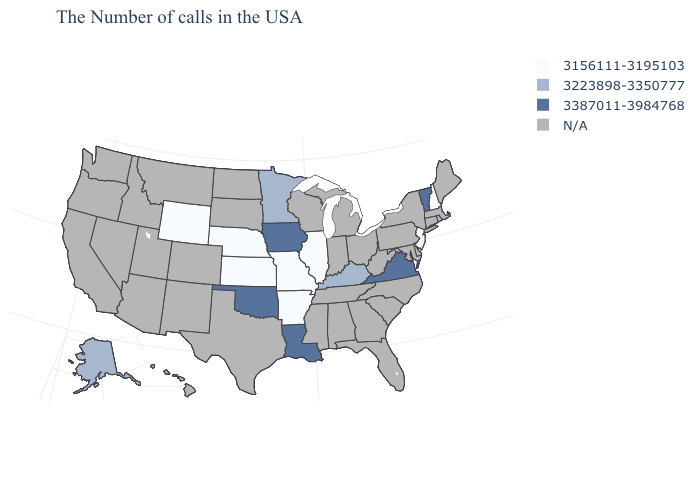What is the value of New Jersey?
Write a very short answer. 3156111-3195103. What is the value of Iowa?
Concise answer only. 3387011-3984768. What is the lowest value in the USA?
Answer briefly. 3156111-3195103. What is the value of California?
Quick response, please. N/A. What is the lowest value in the USA?
Keep it brief. 3156111-3195103. What is the lowest value in the Northeast?
Short answer required. 3156111-3195103. Which states have the lowest value in the South?
Short answer required. Arkansas. Does Nebraska have the lowest value in the USA?
Answer briefly. Yes. Does Nebraska have the highest value in the MidWest?
Write a very short answer. No. Name the states that have a value in the range 3387011-3984768?
Keep it brief. Vermont, Virginia, Louisiana, Iowa, Oklahoma. What is the value of Ohio?
Quick response, please. N/A. Which states have the highest value in the USA?
Quick response, please. Vermont, Virginia, Louisiana, Iowa, Oklahoma. 